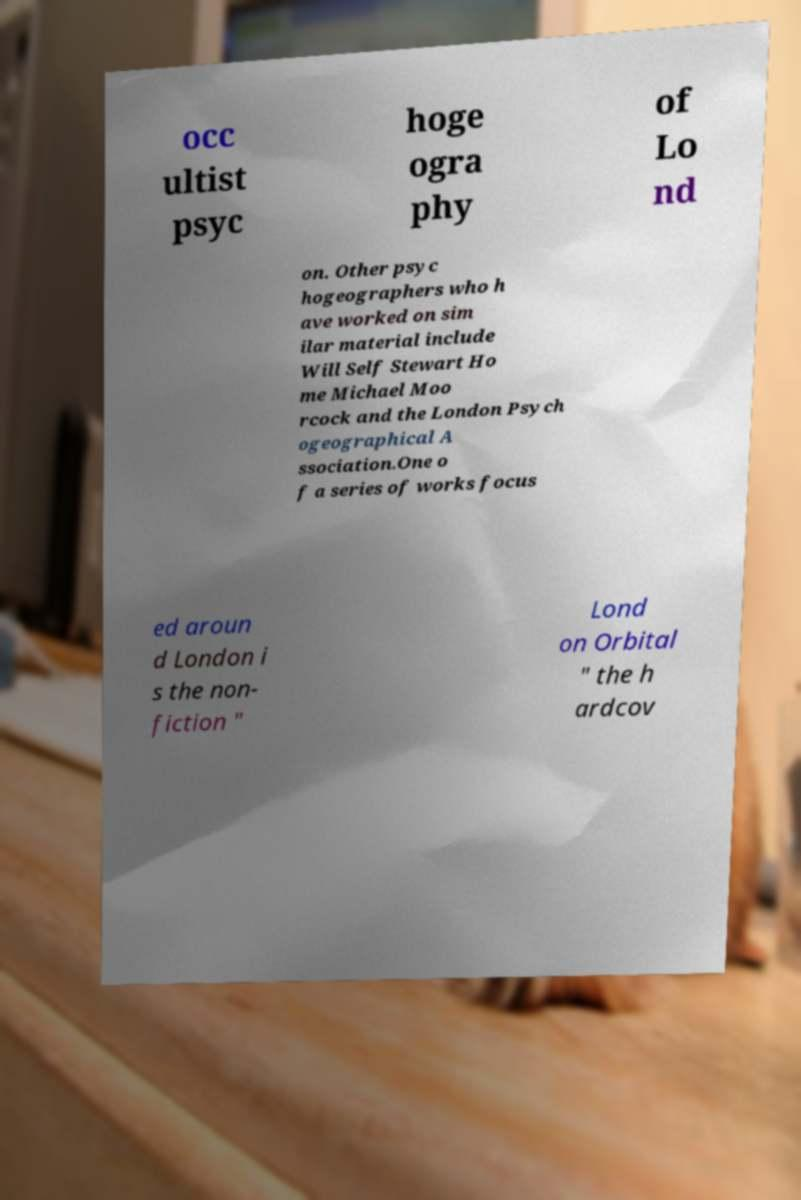For documentation purposes, I need the text within this image transcribed. Could you provide that? occ ultist psyc hoge ogra phy of Lo nd on. Other psyc hogeographers who h ave worked on sim ilar material include Will Self Stewart Ho me Michael Moo rcock and the London Psych ogeographical A ssociation.One o f a series of works focus ed aroun d London i s the non- fiction " Lond on Orbital " the h ardcov 